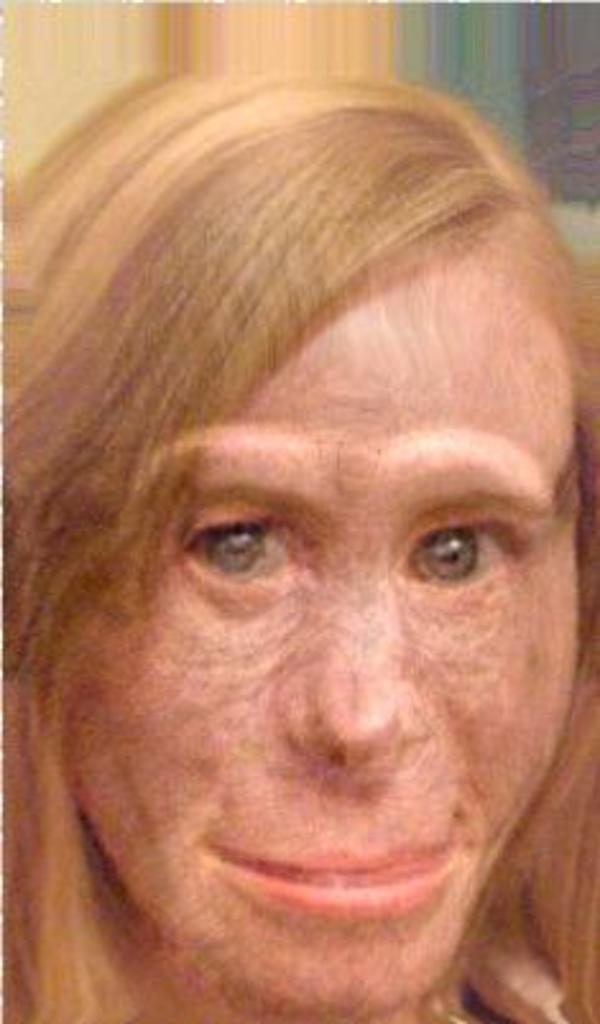What is the main subject of the image? The main subject of the image is an edited picture of a woman. Can you see any dust particles on the floor in the image? There is no mention of dust or a floor in the provided fact, so it cannot be determined if they are present in the image. 